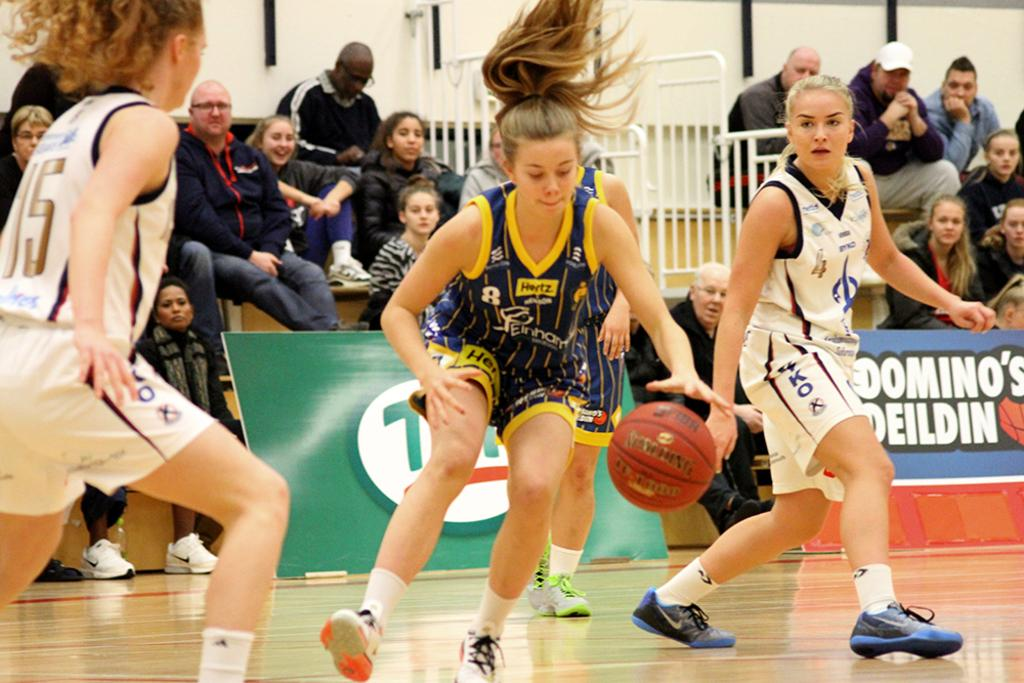<image>
Write a terse but informative summary of the picture. The girl in the middle is wearing a top which is sponsored by hertz. 